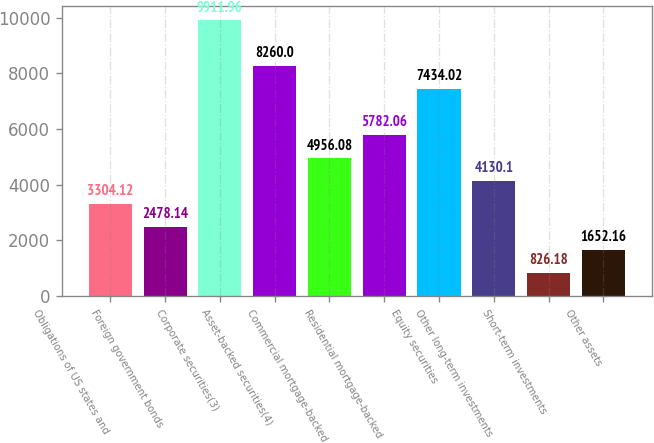Convert chart to OTSL. <chart><loc_0><loc_0><loc_500><loc_500><bar_chart><fcel>Obligations of US states and<fcel>Foreign government bonds<fcel>Corporate securities(3)<fcel>Asset-backed securities(4)<fcel>Commercial mortgage-backed<fcel>Residential mortgage-backed<fcel>Equity securities<fcel>Other long-term investments<fcel>Short-term investments<fcel>Other assets<nl><fcel>3304.12<fcel>2478.14<fcel>9911.96<fcel>8260<fcel>4956.08<fcel>5782.06<fcel>7434.02<fcel>4130.1<fcel>826.18<fcel>1652.16<nl></chart> 